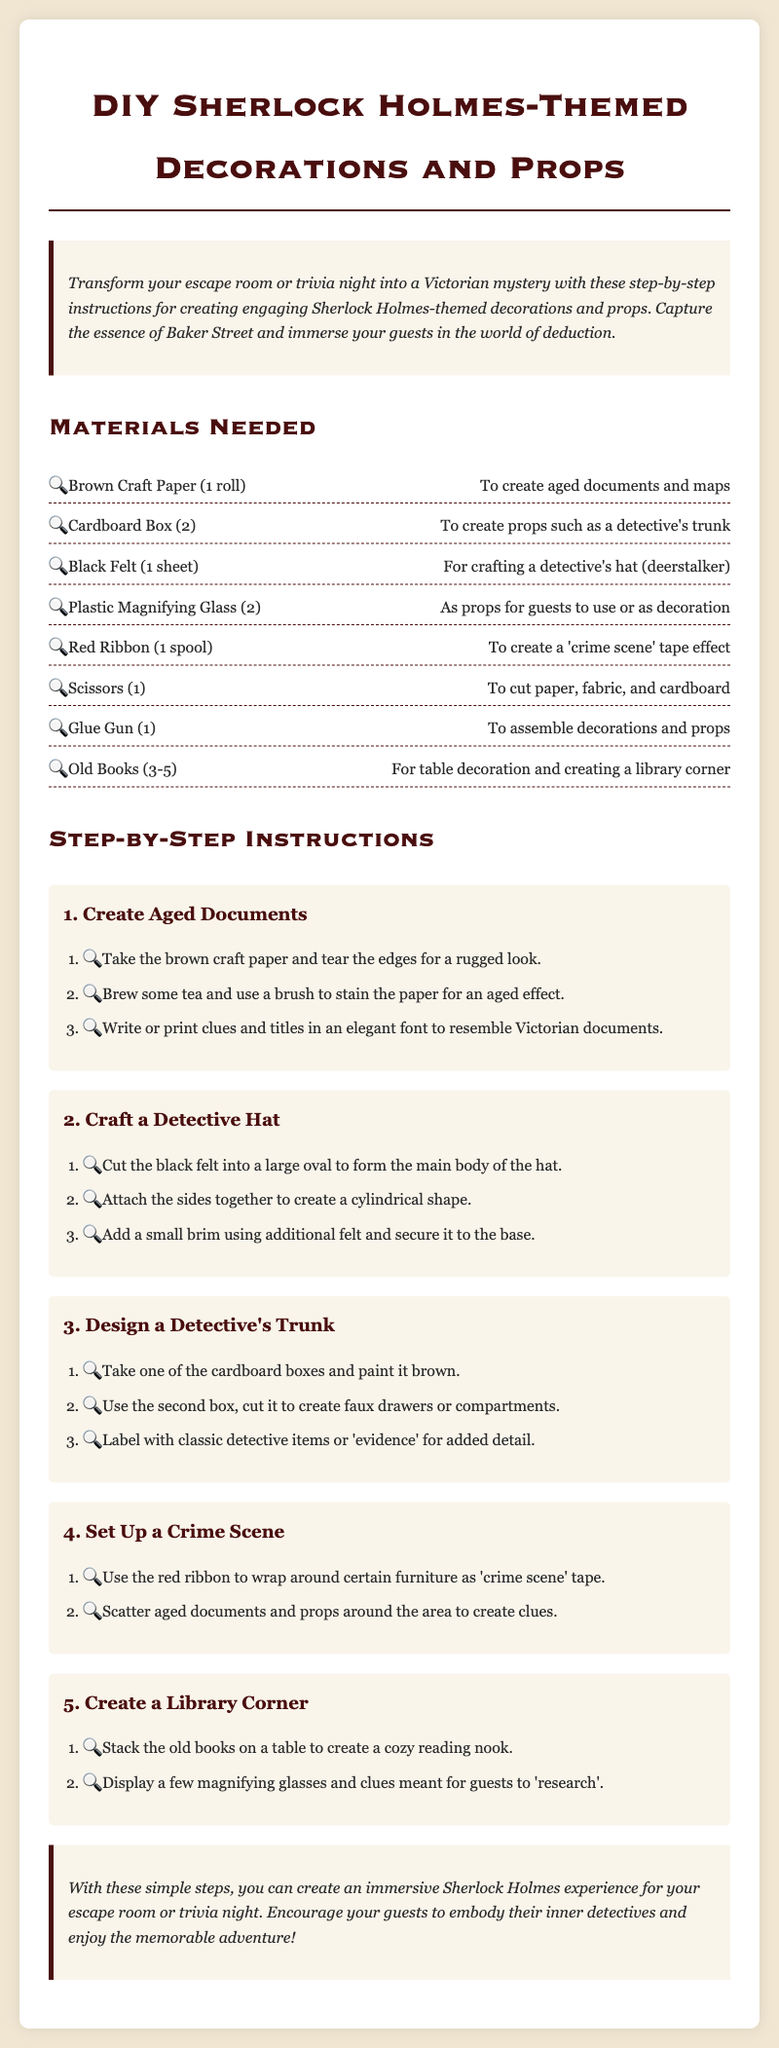what are the dimensions of the cardboard boxes needed? The document mentions using two cardboard boxes without specific dimensions.
Answer: 2 how many sheets of black felt are required? The materials list states that one sheet of black felt is needed for crafting a detective's hat.
Answer: 1 sheet what is used to create aged documents? The instructions suggest using brown craft paper and tea to stain the paper for an aged effect.
Answer: brown craft paper and tea how many old books should be used for the library corner? The materials section recommends using three to five old books for creating a cozy reading nook.
Answer: 3-5 what color is the ribbon used for crime scene tape? The decoration utilizes red ribbon as crime scene tape effect.
Answer: red which prop is suggested as an item for guests to use? The document includes plastic magnifying glasses as props guests can use.
Answer: plastic magnifying glasses what step involves creating faux drawers? The trunk design includes cutting the second cardboard box to create faux drawers or compartments.
Answer: Design a Detective's Trunk where should you stack the old books? The instructions recommend stacking the old books on a table to create a reading nook.
Answer: on a table 